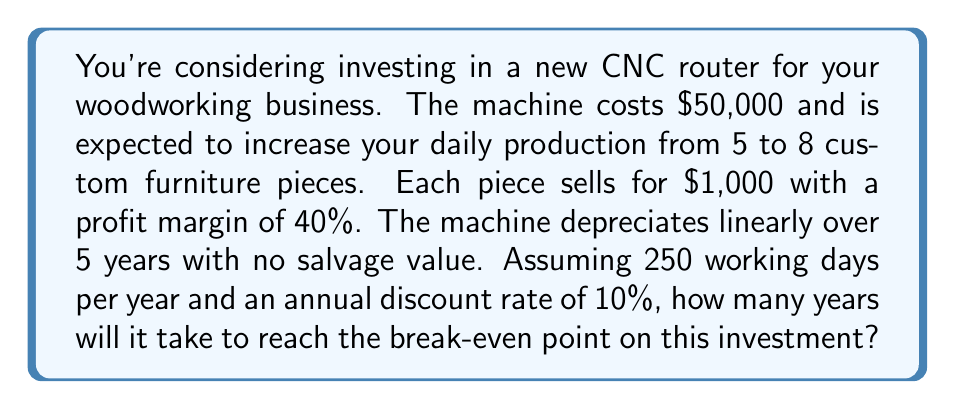Could you help me with this problem? Let's approach this problem step-by-step:

1) First, calculate the daily increase in profit:
   - Increase in production: 8 - 5 = 3 pieces/day
   - Profit per piece: $1,000 × 40% = $400
   - Daily profit increase: 3 × $400 = $1,200

2) Calculate the annual profit increase:
   Annual profit increase = $1,200 × 250 days = $300,000

3) Calculate annual depreciation:
   Annual depreciation = $50,000 / 5 years = $10,000

4) Net annual cash flow:
   $300,000 - $10,000 = $290,000

5) To find the break-even point, we need to calculate the present value of these cash flows and compare them to the initial investment. We'll use the following formula:

   $$PV = \sum_{t=1}^{n} \frac{CF_t}{(1+r)^t}$$

   Where:
   PV = Present Value
   $CF_t$ = Cash Flow in year t
   r = Discount rate
   n = Number of years

6) We'll iterate through years until the cumulative present value exceeds the initial investment:

   Year 1: $\frac{290,000}{(1+0.1)^1} = 263,636.36$
   Year 2: $263,636.36 + \frac{290,000}{(1+0.1)^2} = 502,396.69$

   The cumulative present value after 2 years exceeds the initial investment of $50,000.
Answer: The break-even point is reached in 2 years. 